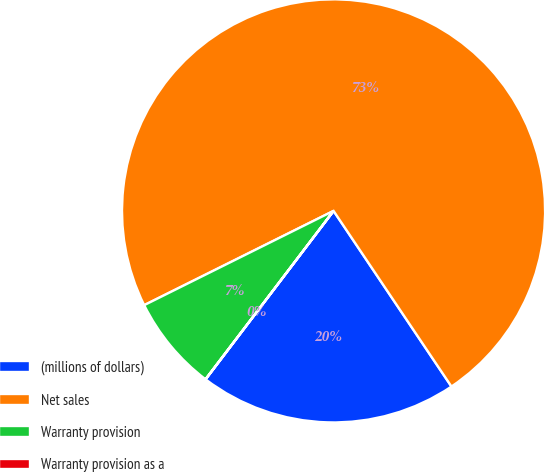Convert chart to OTSL. <chart><loc_0><loc_0><loc_500><loc_500><pie_chart><fcel>(millions of dollars)<fcel>Net sales<fcel>Warranty provision<fcel>Warranty provision as a<nl><fcel>19.75%<fcel>72.95%<fcel>7.3%<fcel>0.01%<nl></chart> 